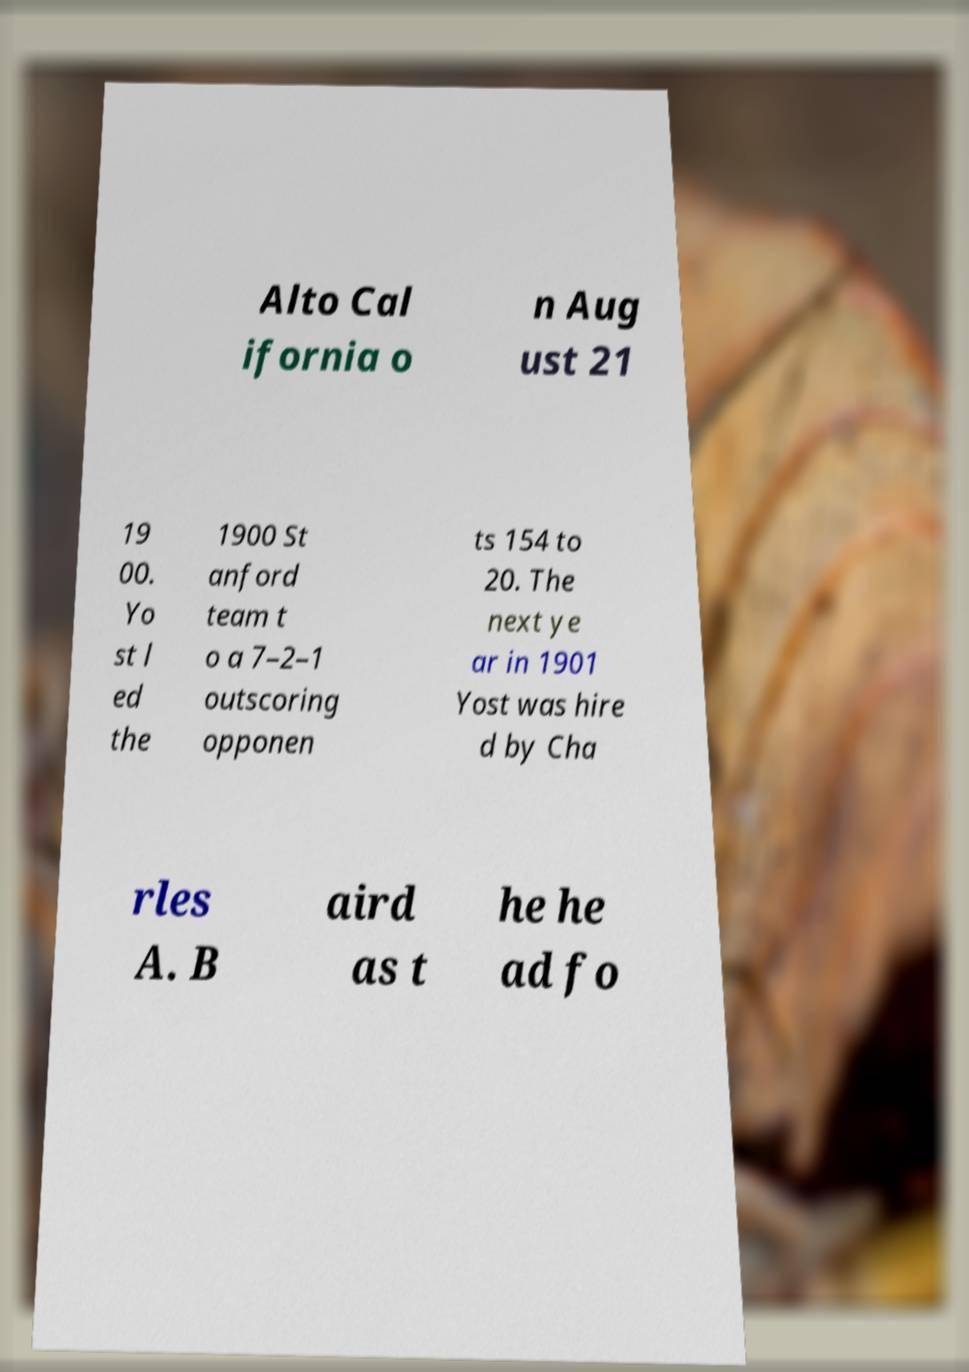I need the written content from this picture converted into text. Can you do that? Alto Cal ifornia o n Aug ust 21 19 00. Yo st l ed the 1900 St anford team t o a 7–2–1 outscoring opponen ts 154 to 20. The next ye ar in 1901 Yost was hire d by Cha rles A. B aird as t he he ad fo 